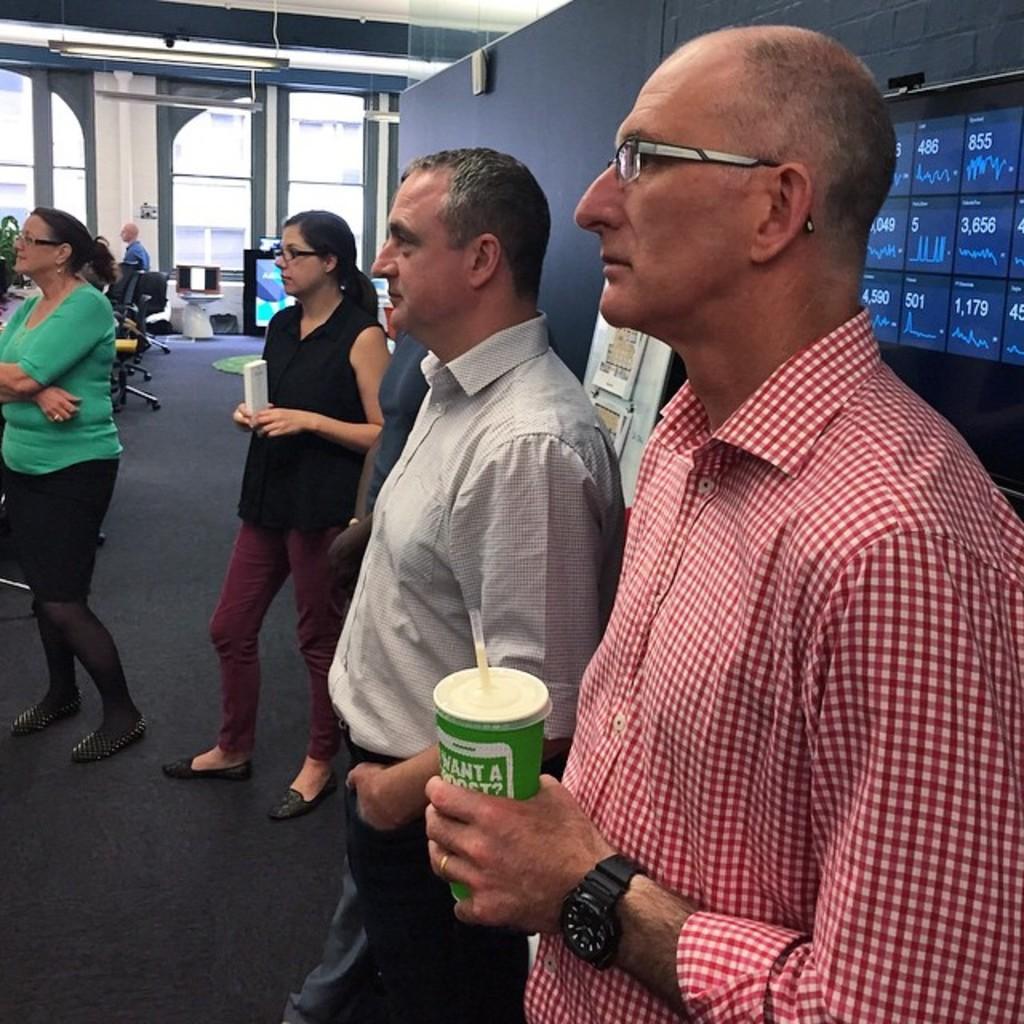Describe this image in one or two sentences. This image consists of many persons. In the front, the man wearing red shirt is holding a cup. At the bottom, there is a floor, on which we can see a floor mat in black color. On the right, there is a screen. In the front, there are windows. And there are many chairs in this image. At the top, there is a roof along with lights. 